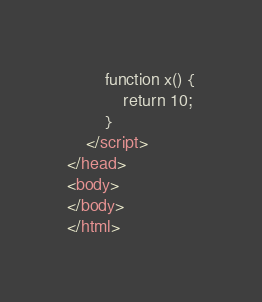<code> <loc_0><loc_0><loc_500><loc_500><_HTML_>		function x() {
			return 10;
		}
	</script>
</head>
<body>
</body>
</html>

</code> 